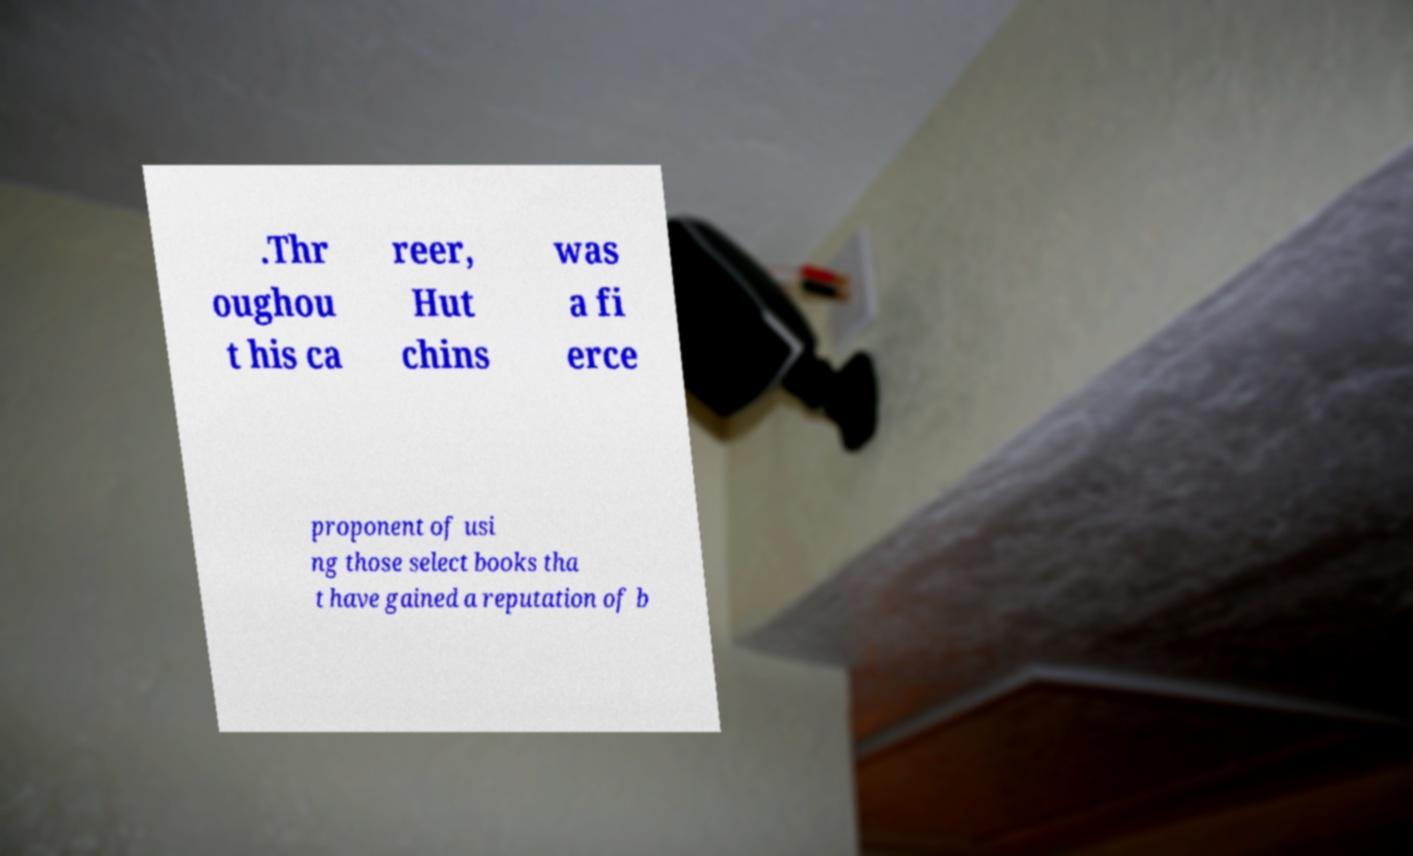Please read and relay the text visible in this image. What does it say? .Thr oughou t his ca reer, Hut chins was a fi erce proponent of usi ng those select books tha t have gained a reputation of b 